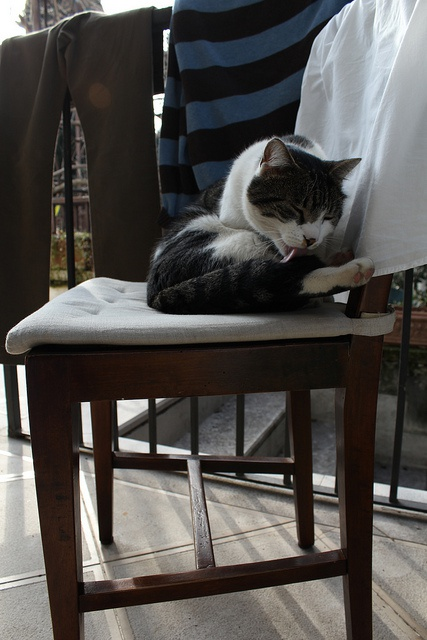Describe the objects in this image and their specific colors. I can see chair in white, black, darkgray, gray, and lightgray tones and cat in white, black, gray, darkgray, and lightgray tones in this image. 